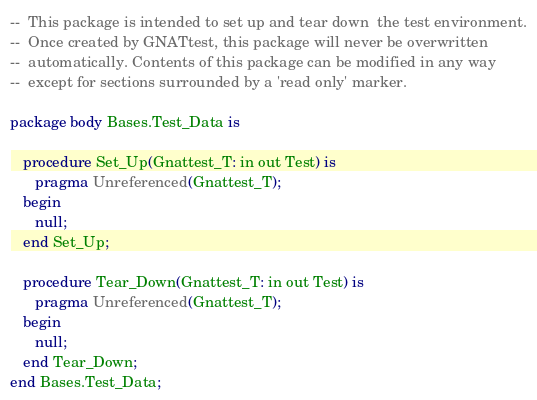Convert code to text. <code><loc_0><loc_0><loc_500><loc_500><_Ada_>--  This package is intended to set up and tear down  the test environment.
--  Once created by GNATtest, this package will never be overwritten
--  automatically. Contents of this package can be modified in any way
--  except for sections surrounded by a 'read only' marker.

package body Bases.Test_Data is

   procedure Set_Up(Gnattest_T: in out Test) is
      pragma Unreferenced(Gnattest_T);
   begin
      null;
   end Set_Up;

   procedure Tear_Down(Gnattest_T: in out Test) is
      pragma Unreferenced(Gnattest_T);
   begin
      null;
   end Tear_Down;
end Bases.Test_Data;
</code> 